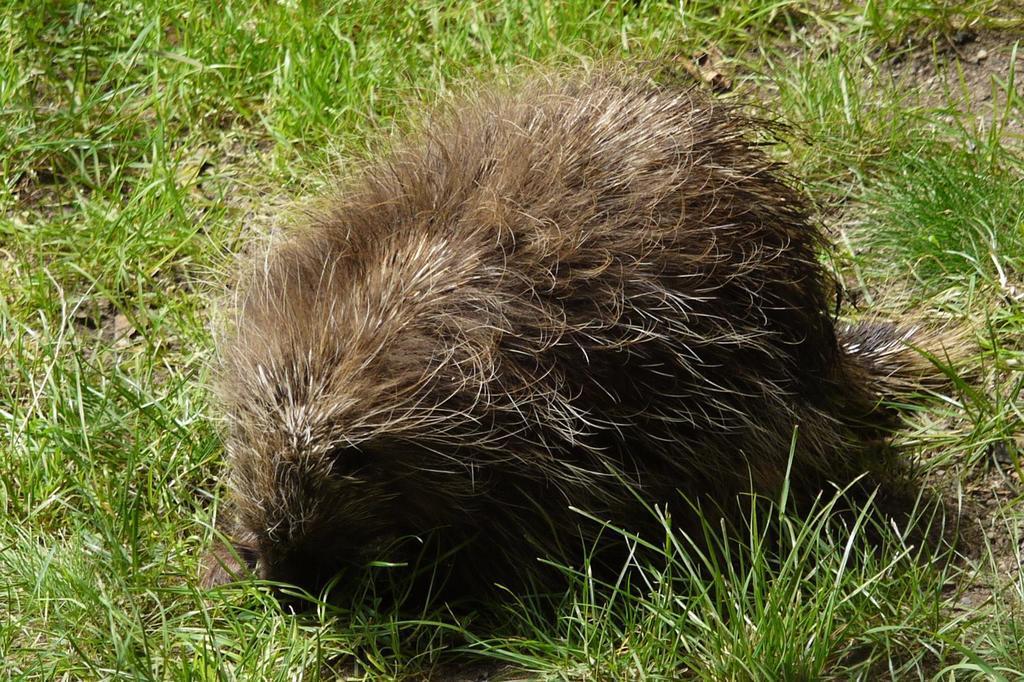Could you give a brief overview of what you see in this image? In the center of the image we can see the porcupine on the grass. 